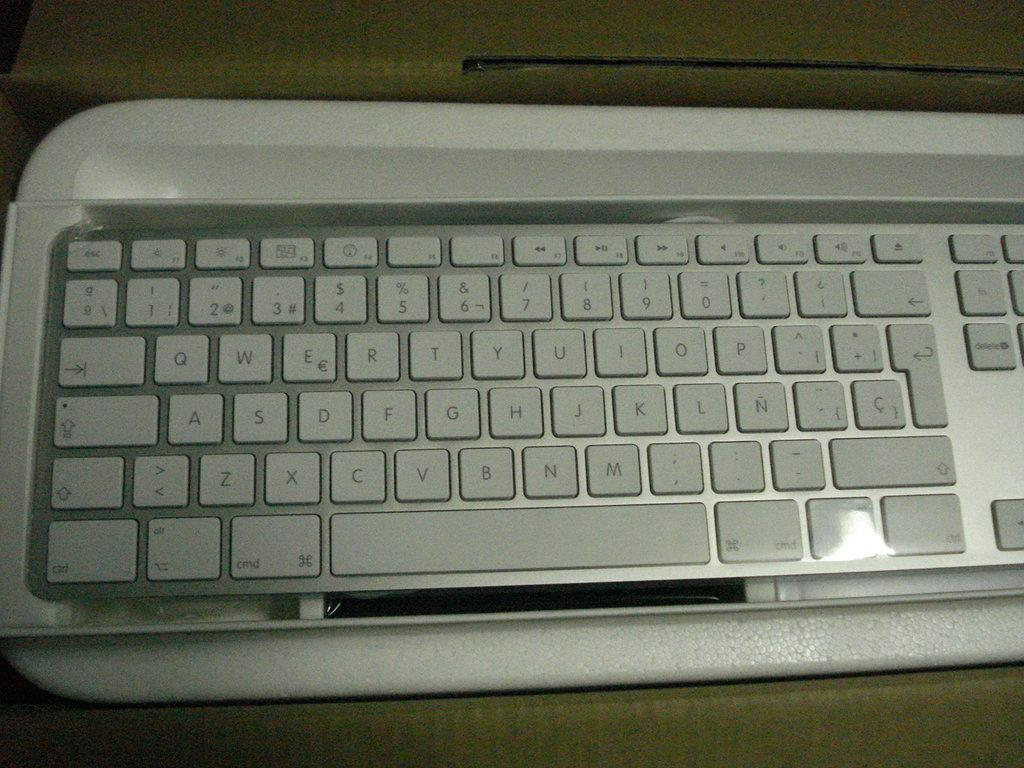Provide a one-sentence caption for the provided image. Keyboard with the letters S,D,F and more visible. 